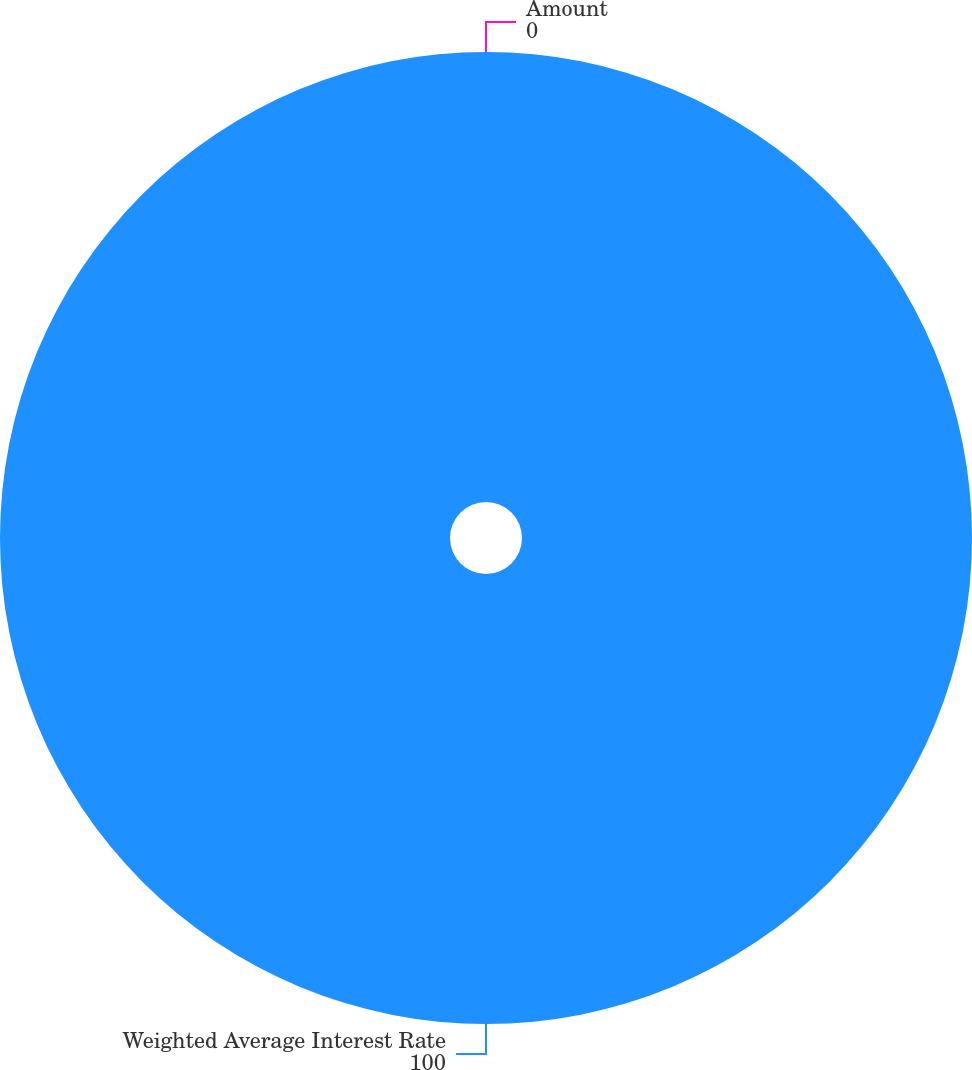<chart> <loc_0><loc_0><loc_500><loc_500><pie_chart><fcel>Weighted Average Interest Rate<fcel>Amount<nl><fcel>100.0%<fcel>0.0%<nl></chart> 